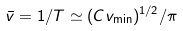Convert formula to latex. <formula><loc_0><loc_0><loc_500><loc_500>\bar { v } = 1 / T \simeq ( C v _ { \min } ) ^ { 1 / 2 } / \pi</formula> 